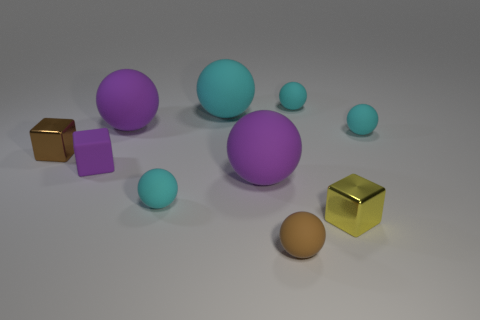What is the material of the purple cube?
Your answer should be compact. Rubber. There is a purple object behind the purple matte cube; what shape is it?
Make the answer very short. Sphere. What color is the matte cube that is the same size as the yellow metallic object?
Keep it short and to the point. Purple. Is the small purple cube on the left side of the small yellow block made of the same material as the large cyan object?
Keep it short and to the point. Yes. There is a cyan matte sphere that is to the left of the yellow metal thing and on the right side of the brown rubber ball; how big is it?
Provide a succinct answer. Small. What is the size of the block in front of the tiny purple object?
Keep it short and to the point. Small. There is a small shiny object to the left of the brown object that is right of the metallic block that is to the left of the large cyan ball; what is its shape?
Make the answer very short. Cube. What number of other things are there of the same shape as the large cyan object?
Ensure brevity in your answer.  6. What number of metallic things are tiny brown objects or small balls?
Provide a succinct answer. 1. There is a sphere that is in front of the tiny shiny cube right of the brown ball; what is it made of?
Provide a short and direct response. Rubber. 